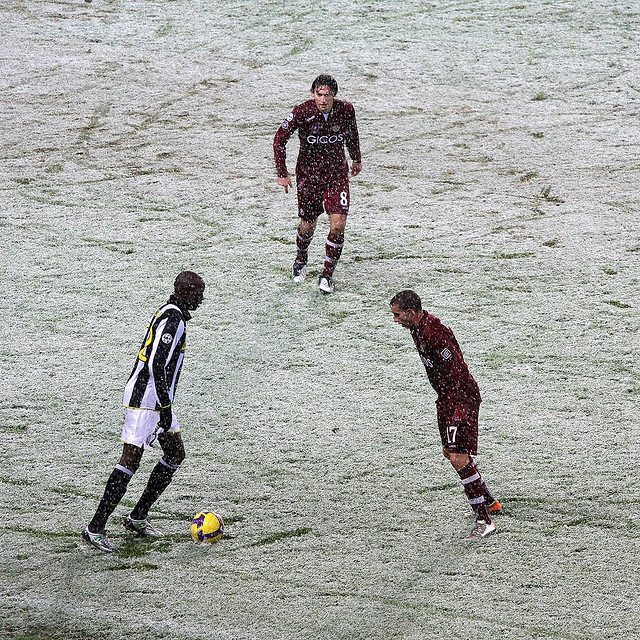Describe the objects in this image and their specific colors. I can see people in lightgray, black, lavender, gray, and darkgray tones, people in lightgray, black, gray, maroon, and darkgray tones, people in lightgray, black, maroon, gray, and darkgray tones, and sports ball in lightgray, khaki, gold, black, and olive tones in this image. 